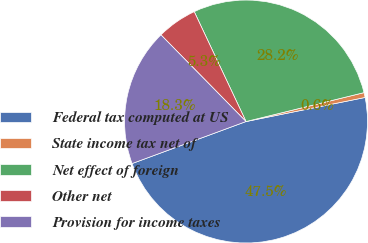<chart> <loc_0><loc_0><loc_500><loc_500><pie_chart><fcel>Federal tax computed at US<fcel>State income tax net of<fcel>Net effect of foreign<fcel>Other net<fcel>Provision for income taxes<nl><fcel>47.55%<fcel>0.65%<fcel>28.19%<fcel>5.34%<fcel>18.27%<nl></chart> 